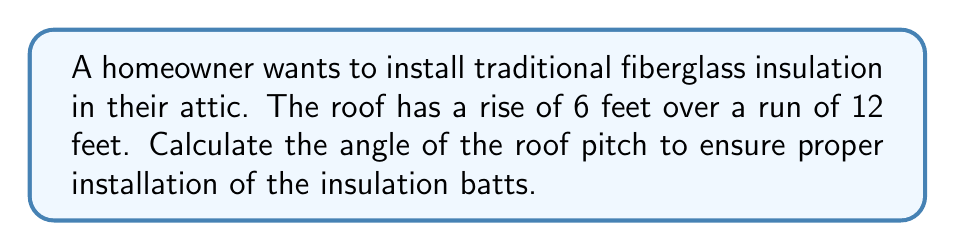Solve this math problem. To find the angle of the roof pitch, we need to use trigonometry. The rise and run form a right triangle with the roof surface.

Step 1: Identify the triangle components
- Rise = 6 feet (opposite side)
- Run = 12 feet (adjacent side)

Step 2: Determine which trigonometric function to use
We have the opposite and adjacent sides, so we'll use the tangent function:

$$ \tan(\theta) = \frac{\text{opposite}}{\text{adjacent}} $$

Step 3: Plug in the values
$$ \tan(\theta) = \frac{6}{12} = \frac{1}{2} $$

Step 4: Solve for the angle using the inverse tangent (arctangent)
$$ \theta = \tan^{-1}\left(\frac{1}{2}\right) $$

Step 5: Calculate the result
$$ \theta \approx 26.57° $$

[asy]
import geometry;

size(200);
pair A=(0,0), B=(12,0), C=(0,6);
draw(A--B--C--A);
draw(B--C,dashed);
label("6'",C--A,W);
label("12'",A--B,S);
label("$\theta$",A,NE);
markright(A,0.5);
[/asy]
Answer: $26.57°$ 